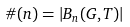Convert formula to latex. <formula><loc_0><loc_0><loc_500><loc_500>\# ( n ) = | B _ { n } ( G , T ) |</formula> 